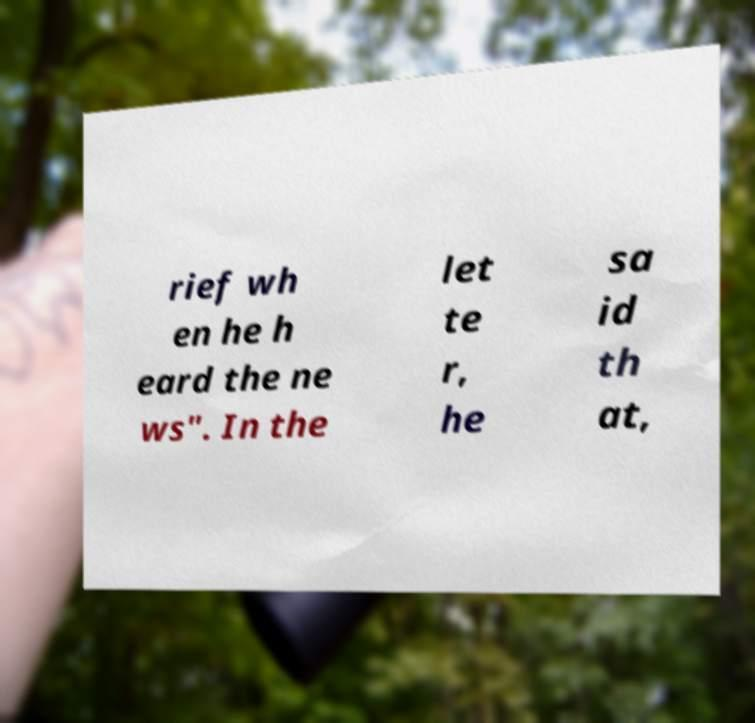For documentation purposes, I need the text within this image transcribed. Could you provide that? rief wh en he h eard the ne ws". In the let te r, he sa id th at, 